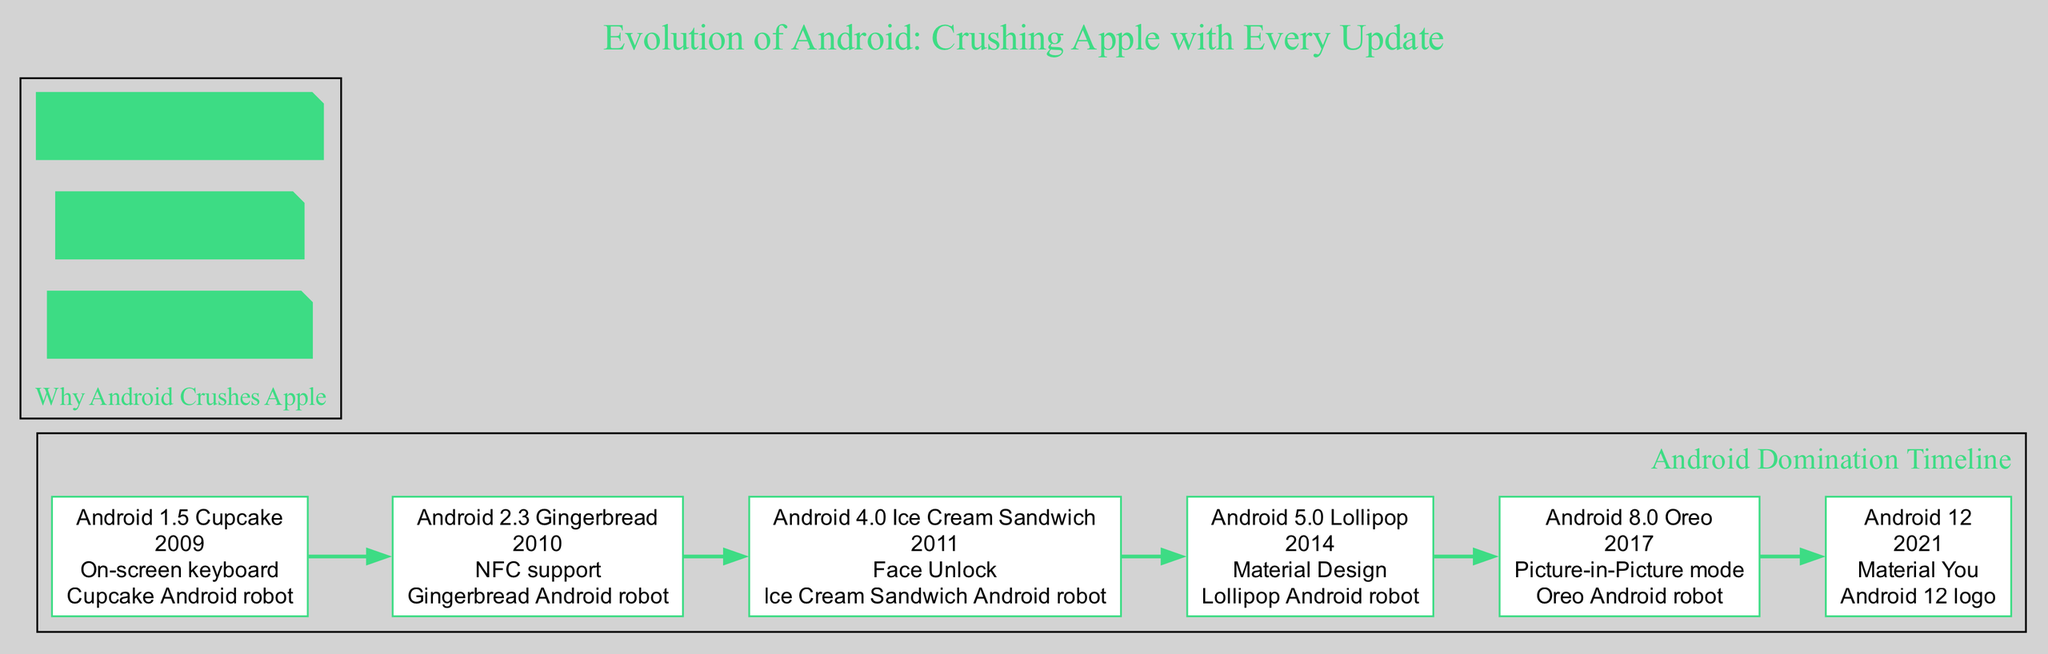What is the key feature of Android 5.0? Referring to the node for Android 5.0 Lollipop, the key feature listed is "Material Design."
Answer: Material Design In what year was Android 8.0 released? The node for Android 8.0 Oreo shows that it was released in the year "2017."
Answer: 2017 Which version introduced Face Unlock? By checking the timeline nodes, Face Unlock is highlighted as the key feature for Android 4.0 Ice Cream Sandwich.
Answer: Android 4.0 Ice Cream Sandwich How many major Android versions are represented in the diagram? The diagram contains six distinct version nodes from Android 1.5 Cupcake to Android 12.
Answer: 6 Which mascot corresponds to Android 2.3? The nodal representation for Android 2.3 indicates its mascot is the "Gingerbread Android robot."
Answer: Gingerbread Android robot What is the main theme emphasized in the side notes? Looking at the side notes, the notes emphasize "Open-source superiority" as a major theme.
Answer: Open-source superiority What feature was introduced with Android 12? The node for Android 12 specifies that the introduced feature is "Material You."
Answer: Material You Which version came after Android 4.0? By analyzing the flow of edges connecting nodes, the version that follows Android 4.0 Ice Cream Sandwich is Android 5.0 Lollipop.
Answer: Android 5.0 Lollipop What unique function does Android 8.0 support? The timeline for Android 8.0 Oreo notes that it supports "Picture-in-Picture mode."
Answer: Picture-in-Picture mode Which version has a robot mascot representing a dessert? The diagram reveals that "Gingerbread Android robot" is the mascot for Android 2.3, which is named after a dessert.
Answer: Gingerbread Android robot 